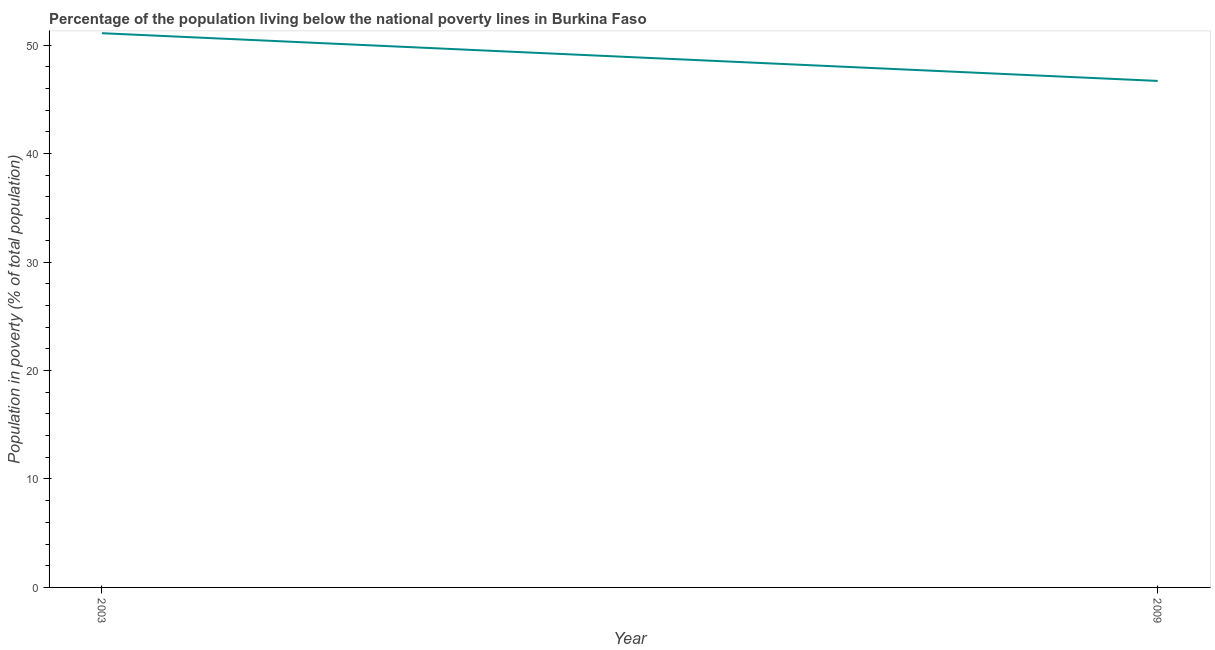What is the percentage of population living below poverty line in 2009?
Offer a terse response. 46.7. Across all years, what is the maximum percentage of population living below poverty line?
Give a very brief answer. 51.1. Across all years, what is the minimum percentage of population living below poverty line?
Provide a short and direct response. 46.7. In which year was the percentage of population living below poverty line maximum?
Your answer should be very brief. 2003. What is the sum of the percentage of population living below poverty line?
Offer a terse response. 97.8. What is the difference between the percentage of population living below poverty line in 2003 and 2009?
Keep it short and to the point. 4.4. What is the average percentage of population living below poverty line per year?
Your response must be concise. 48.9. What is the median percentage of population living below poverty line?
Keep it short and to the point. 48.9. In how many years, is the percentage of population living below poverty line greater than 44 %?
Make the answer very short. 2. Do a majority of the years between 2009 and 2003 (inclusive) have percentage of population living below poverty line greater than 34 %?
Keep it short and to the point. No. What is the ratio of the percentage of population living below poverty line in 2003 to that in 2009?
Give a very brief answer. 1.09. Is the percentage of population living below poverty line in 2003 less than that in 2009?
Your answer should be compact. No. How many years are there in the graph?
Make the answer very short. 2. What is the difference between two consecutive major ticks on the Y-axis?
Give a very brief answer. 10. What is the title of the graph?
Offer a very short reply. Percentage of the population living below the national poverty lines in Burkina Faso. What is the label or title of the X-axis?
Provide a short and direct response. Year. What is the label or title of the Y-axis?
Make the answer very short. Population in poverty (% of total population). What is the Population in poverty (% of total population) in 2003?
Keep it short and to the point. 51.1. What is the Population in poverty (% of total population) in 2009?
Offer a terse response. 46.7. What is the difference between the Population in poverty (% of total population) in 2003 and 2009?
Your answer should be very brief. 4.4. What is the ratio of the Population in poverty (% of total population) in 2003 to that in 2009?
Your response must be concise. 1.09. 